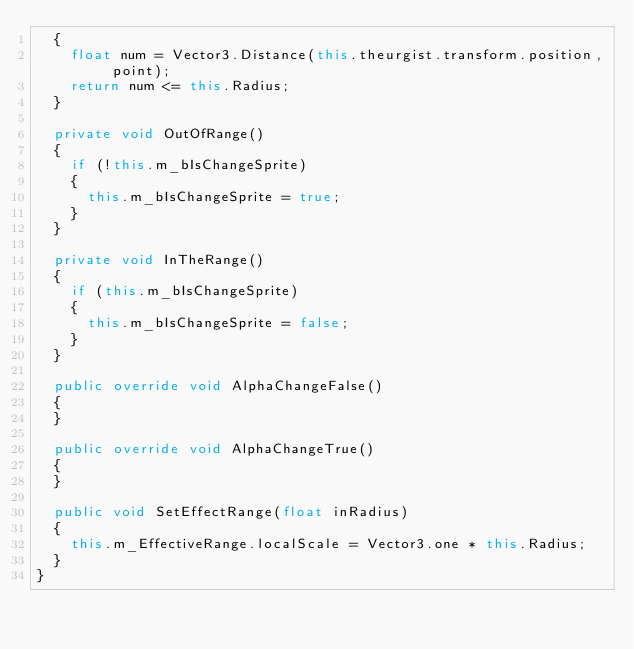Convert code to text. <code><loc_0><loc_0><loc_500><loc_500><_C#_>	{
		float num = Vector3.Distance(this.theurgist.transform.position, point);
		return num <= this.Radius;
	}

	private void OutOfRange()
	{
		if (!this.m_bIsChangeSprite)
		{
			this.m_bIsChangeSprite = true;
		}
	}

	private void InTheRange()
	{
		if (this.m_bIsChangeSprite)
		{
			this.m_bIsChangeSprite = false;
		}
	}

	public override void AlphaChangeFalse()
	{
	}

	public override void AlphaChangeTrue()
	{
	}

	public void SetEffectRange(float inRadius)
	{
		this.m_EffectiveRange.localScale = Vector3.one * this.Radius;
	}
}
</code> 